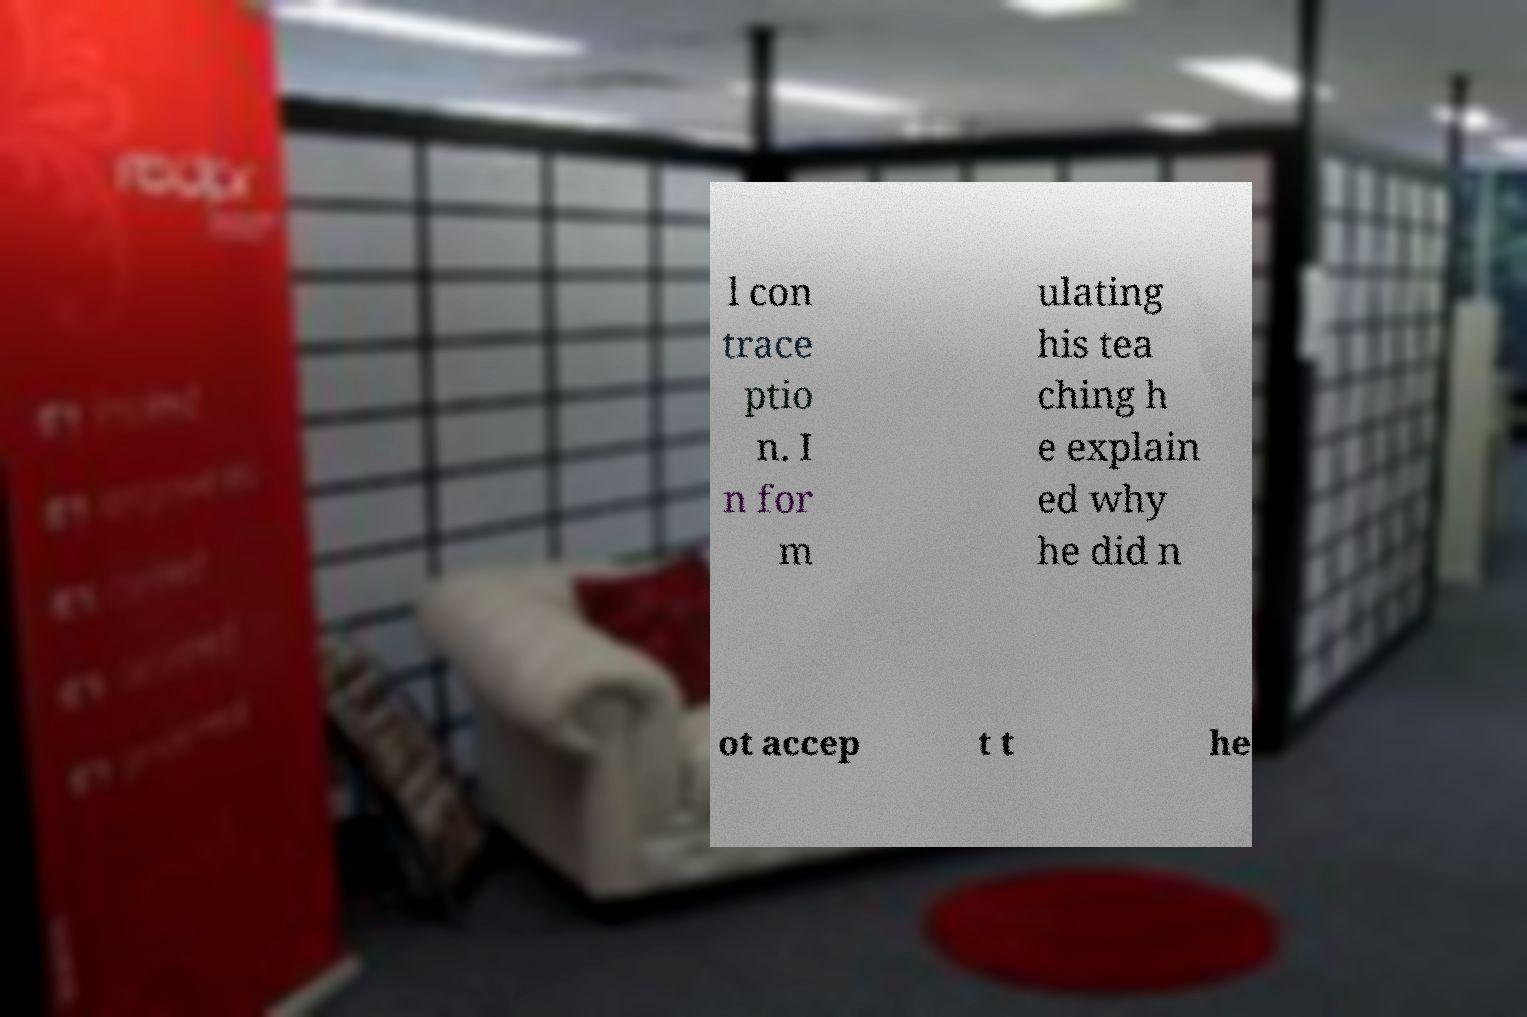Please read and relay the text visible in this image. What does it say? l con trace ptio n. I n for m ulating his tea ching h e explain ed why he did n ot accep t t he 